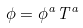Convert formula to latex. <formula><loc_0><loc_0><loc_500><loc_500>\phi = \phi ^ { a } T ^ { a }</formula> 